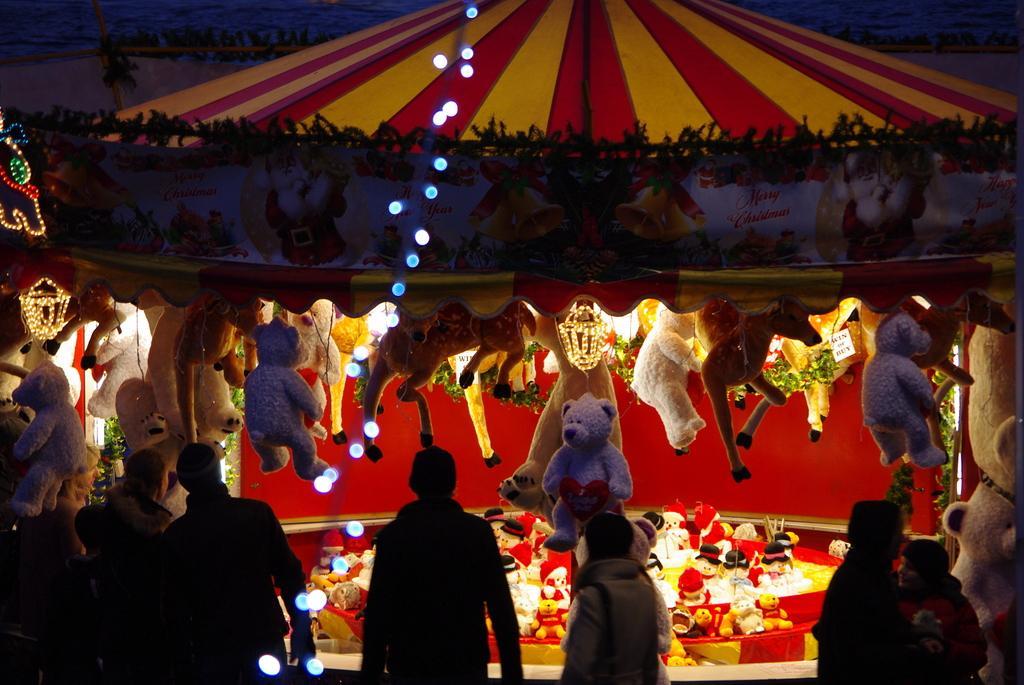In one or two sentences, can you explain what this image depicts? In this picture there are people and we can see dolls, tent, lights, banner and decorative items. 